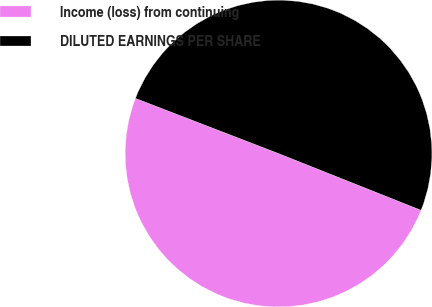Convert chart to OTSL. <chart><loc_0><loc_0><loc_500><loc_500><pie_chart><fcel>Income (loss) from continuing<fcel>DILUTED EARNINGS PER SHARE<nl><fcel>49.83%<fcel>50.17%<nl></chart> 